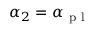<formula> <loc_0><loc_0><loc_500><loc_500>\alpha _ { 2 } = \alpha _ { p l }</formula> 